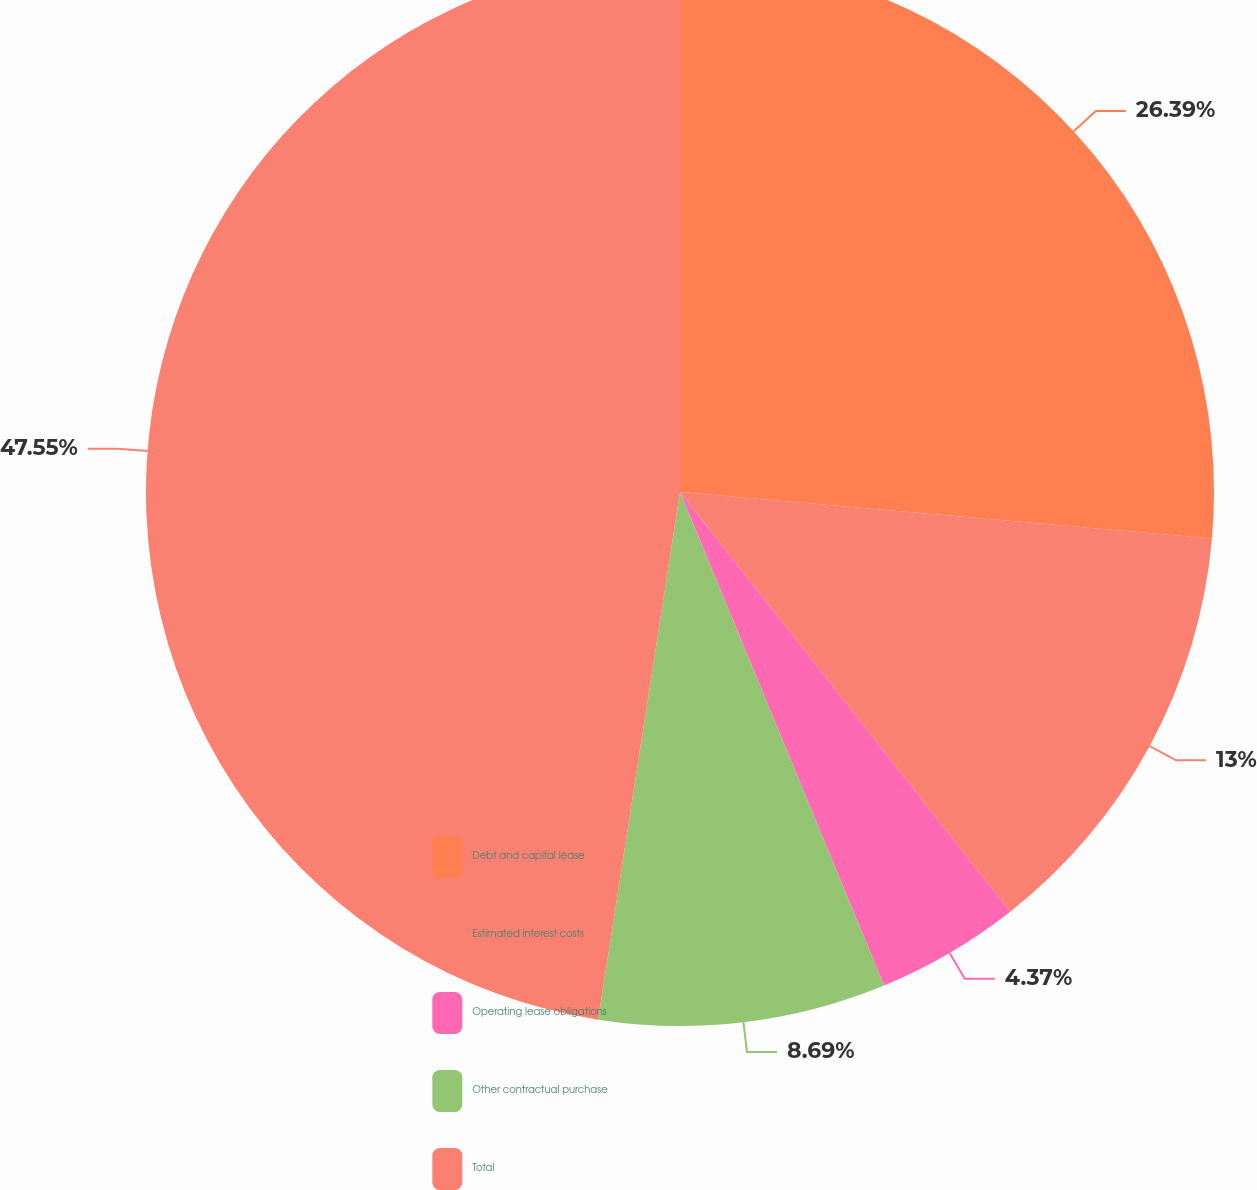Convert chart. <chart><loc_0><loc_0><loc_500><loc_500><pie_chart><fcel>Debt and capital lease<fcel>Estimated interest costs<fcel>Operating lease obligations<fcel>Other contractual purchase<fcel>Total<nl><fcel>26.39%<fcel>13.0%<fcel>4.37%<fcel>8.69%<fcel>47.55%<nl></chart> 